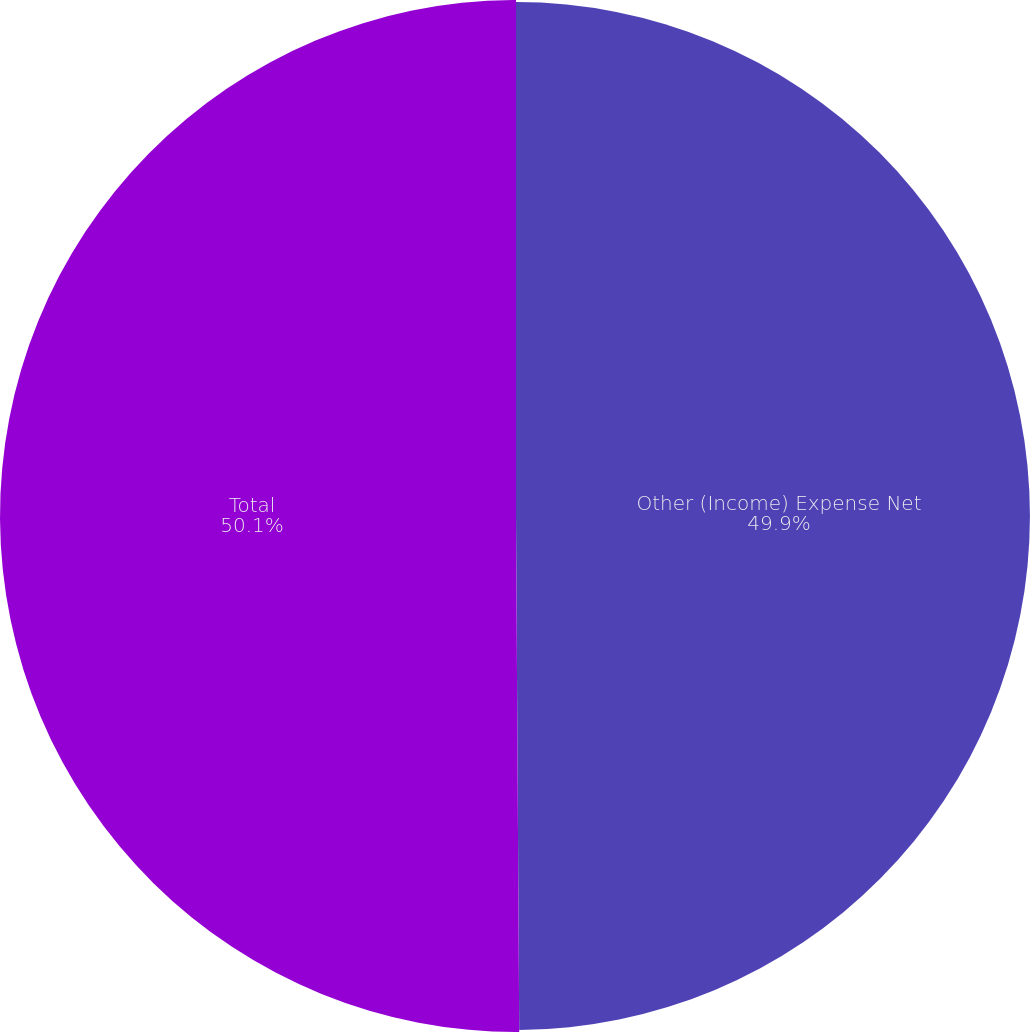Convert chart. <chart><loc_0><loc_0><loc_500><loc_500><pie_chart><fcel>Other (Income) Expense Net<fcel>Total<nl><fcel>49.9%<fcel>50.1%<nl></chart> 